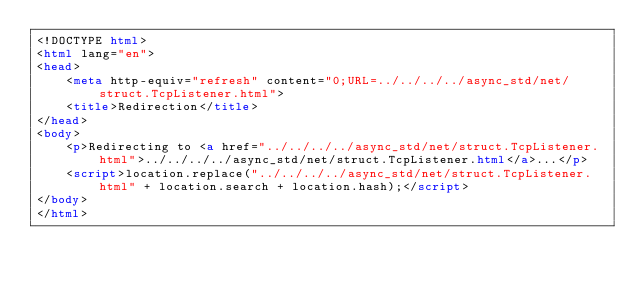Convert code to text. <code><loc_0><loc_0><loc_500><loc_500><_HTML_><!DOCTYPE html>
<html lang="en">
<head>
    <meta http-equiv="refresh" content="0;URL=../../../../async_std/net/struct.TcpListener.html">
    <title>Redirection</title>
</head>
<body>
    <p>Redirecting to <a href="../../../../async_std/net/struct.TcpListener.html">../../../../async_std/net/struct.TcpListener.html</a>...</p>
    <script>location.replace("../../../../async_std/net/struct.TcpListener.html" + location.search + location.hash);</script>
</body>
</html></code> 